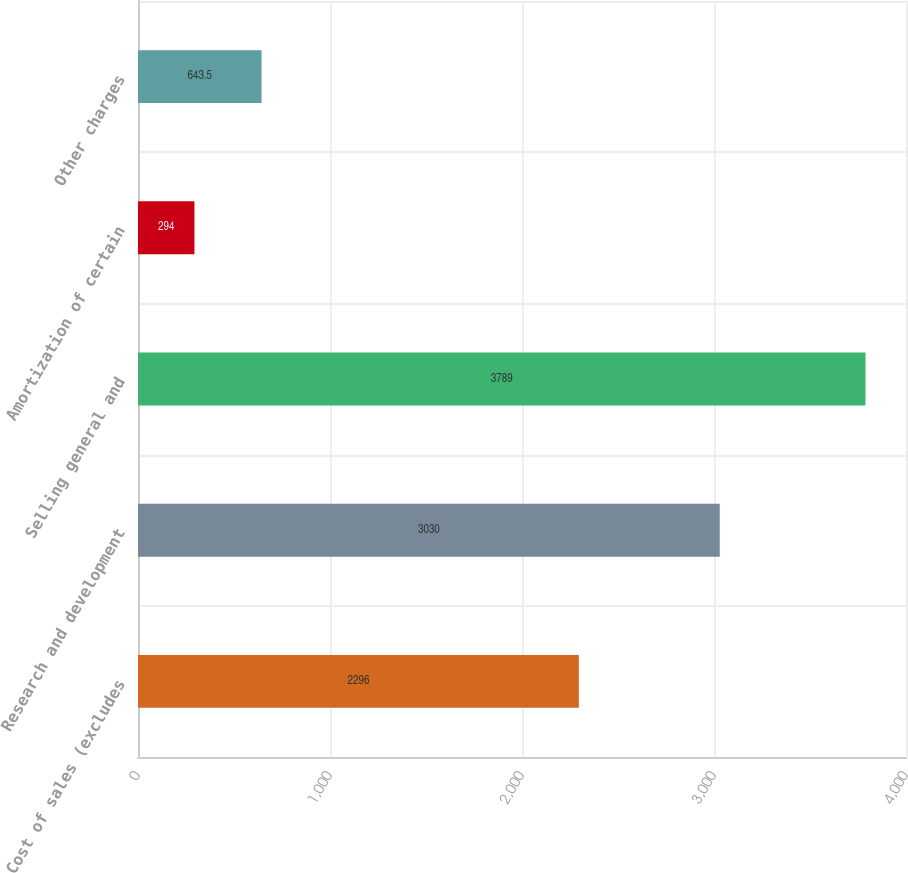Convert chart to OTSL. <chart><loc_0><loc_0><loc_500><loc_500><bar_chart><fcel>Cost of sales (excludes<fcel>Research and development<fcel>Selling general and<fcel>Amortization of certain<fcel>Other charges<nl><fcel>2296<fcel>3030<fcel>3789<fcel>294<fcel>643.5<nl></chart> 